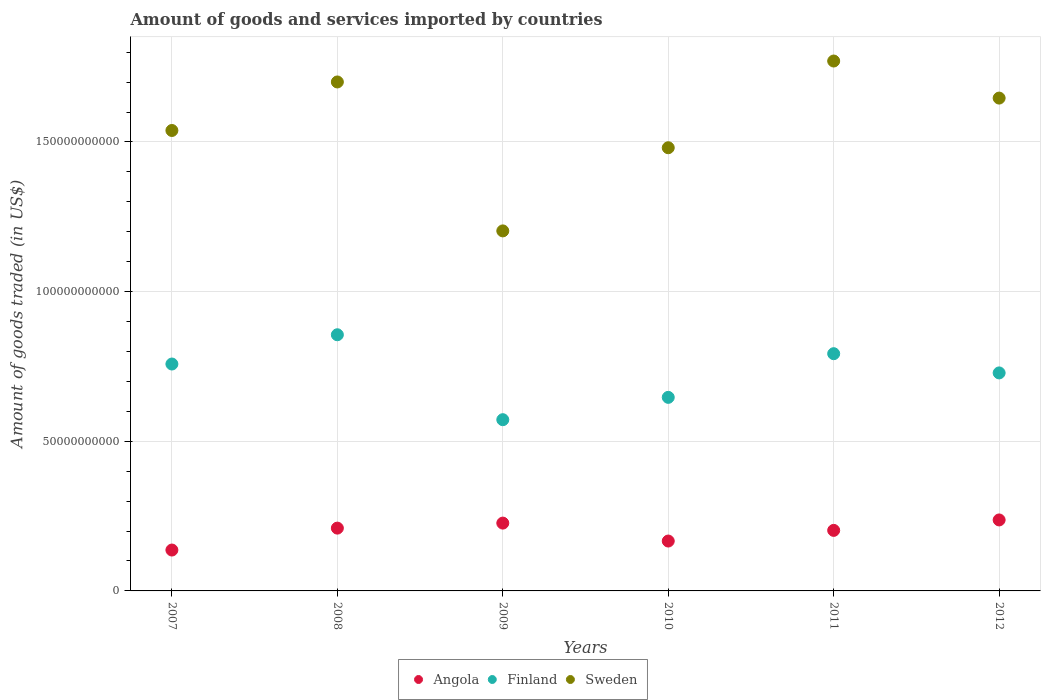Is the number of dotlines equal to the number of legend labels?
Make the answer very short. Yes. What is the total amount of goods and services imported in Sweden in 2008?
Provide a short and direct response. 1.70e+11. Across all years, what is the maximum total amount of goods and services imported in Finland?
Give a very brief answer. 8.56e+1. Across all years, what is the minimum total amount of goods and services imported in Angola?
Keep it short and to the point. 1.37e+1. In which year was the total amount of goods and services imported in Angola maximum?
Offer a terse response. 2012. In which year was the total amount of goods and services imported in Sweden minimum?
Your answer should be very brief. 2009. What is the total total amount of goods and services imported in Angola in the graph?
Offer a very short reply. 1.18e+11. What is the difference between the total amount of goods and services imported in Angola in 2011 and that in 2012?
Your answer should be very brief. -3.49e+09. What is the difference between the total amount of goods and services imported in Finland in 2011 and the total amount of goods and services imported in Angola in 2007?
Keep it short and to the point. 6.56e+1. What is the average total amount of goods and services imported in Sweden per year?
Offer a very short reply. 1.56e+11. In the year 2012, what is the difference between the total amount of goods and services imported in Angola and total amount of goods and services imported in Sweden?
Give a very brief answer. -1.41e+11. What is the ratio of the total amount of goods and services imported in Angola in 2010 to that in 2011?
Offer a very short reply. 0.82. Is the total amount of goods and services imported in Angola in 2007 less than that in 2012?
Ensure brevity in your answer.  Yes. What is the difference between the highest and the second highest total amount of goods and services imported in Angola?
Your answer should be compact. 1.06e+09. What is the difference between the highest and the lowest total amount of goods and services imported in Finland?
Your answer should be very brief. 2.84e+1. In how many years, is the total amount of goods and services imported in Finland greater than the average total amount of goods and services imported in Finland taken over all years?
Ensure brevity in your answer.  4. Is it the case that in every year, the sum of the total amount of goods and services imported in Finland and total amount of goods and services imported in Angola  is greater than the total amount of goods and services imported in Sweden?
Offer a very short reply. No. What is the difference between two consecutive major ticks on the Y-axis?
Make the answer very short. 5.00e+1. Are the values on the major ticks of Y-axis written in scientific E-notation?
Your response must be concise. No. Does the graph contain grids?
Your response must be concise. Yes. Where does the legend appear in the graph?
Your answer should be very brief. Bottom center. What is the title of the graph?
Your answer should be very brief. Amount of goods and services imported by countries. What is the label or title of the Y-axis?
Keep it short and to the point. Amount of goods traded (in US$). What is the Amount of goods traded (in US$) of Angola in 2007?
Your answer should be compact. 1.37e+1. What is the Amount of goods traded (in US$) of Finland in 2007?
Offer a very short reply. 7.58e+1. What is the Amount of goods traded (in US$) in Sweden in 2007?
Keep it short and to the point. 1.54e+11. What is the Amount of goods traded (in US$) of Angola in 2008?
Offer a terse response. 2.10e+1. What is the Amount of goods traded (in US$) of Finland in 2008?
Make the answer very short. 8.56e+1. What is the Amount of goods traded (in US$) of Sweden in 2008?
Your response must be concise. 1.70e+11. What is the Amount of goods traded (in US$) of Angola in 2009?
Your answer should be compact. 2.27e+1. What is the Amount of goods traded (in US$) of Finland in 2009?
Your answer should be compact. 5.72e+1. What is the Amount of goods traded (in US$) in Sweden in 2009?
Offer a terse response. 1.20e+11. What is the Amount of goods traded (in US$) of Angola in 2010?
Give a very brief answer. 1.67e+1. What is the Amount of goods traded (in US$) in Finland in 2010?
Ensure brevity in your answer.  6.47e+1. What is the Amount of goods traded (in US$) of Sweden in 2010?
Give a very brief answer. 1.48e+11. What is the Amount of goods traded (in US$) in Angola in 2011?
Give a very brief answer. 2.02e+1. What is the Amount of goods traded (in US$) in Finland in 2011?
Give a very brief answer. 7.93e+1. What is the Amount of goods traded (in US$) of Sweden in 2011?
Provide a succinct answer. 1.77e+11. What is the Amount of goods traded (in US$) in Angola in 2012?
Ensure brevity in your answer.  2.37e+1. What is the Amount of goods traded (in US$) of Finland in 2012?
Provide a short and direct response. 7.28e+1. What is the Amount of goods traded (in US$) in Sweden in 2012?
Keep it short and to the point. 1.65e+11. Across all years, what is the maximum Amount of goods traded (in US$) of Angola?
Make the answer very short. 2.37e+1. Across all years, what is the maximum Amount of goods traded (in US$) in Finland?
Make the answer very short. 8.56e+1. Across all years, what is the maximum Amount of goods traded (in US$) in Sweden?
Make the answer very short. 1.77e+11. Across all years, what is the minimum Amount of goods traded (in US$) in Angola?
Make the answer very short. 1.37e+1. Across all years, what is the minimum Amount of goods traded (in US$) in Finland?
Provide a succinct answer. 5.72e+1. Across all years, what is the minimum Amount of goods traded (in US$) in Sweden?
Make the answer very short. 1.20e+11. What is the total Amount of goods traded (in US$) of Angola in the graph?
Provide a succinct answer. 1.18e+11. What is the total Amount of goods traded (in US$) in Finland in the graph?
Make the answer very short. 4.35e+11. What is the total Amount of goods traded (in US$) of Sweden in the graph?
Offer a terse response. 9.34e+11. What is the difference between the Amount of goods traded (in US$) in Angola in 2007 and that in 2008?
Make the answer very short. -7.32e+09. What is the difference between the Amount of goods traded (in US$) in Finland in 2007 and that in 2008?
Offer a terse response. -9.78e+09. What is the difference between the Amount of goods traded (in US$) in Sweden in 2007 and that in 2008?
Your answer should be very brief. -1.62e+1. What is the difference between the Amount of goods traded (in US$) in Angola in 2007 and that in 2009?
Provide a short and direct response. -9.00e+09. What is the difference between the Amount of goods traded (in US$) in Finland in 2007 and that in 2009?
Give a very brief answer. 1.86e+1. What is the difference between the Amount of goods traded (in US$) in Sweden in 2007 and that in 2009?
Offer a terse response. 3.36e+1. What is the difference between the Amount of goods traded (in US$) in Angola in 2007 and that in 2010?
Make the answer very short. -3.01e+09. What is the difference between the Amount of goods traded (in US$) of Finland in 2007 and that in 2010?
Offer a very short reply. 1.11e+1. What is the difference between the Amount of goods traded (in US$) of Sweden in 2007 and that in 2010?
Your answer should be very brief. 5.76e+09. What is the difference between the Amount of goods traded (in US$) of Angola in 2007 and that in 2011?
Keep it short and to the point. -6.57e+09. What is the difference between the Amount of goods traded (in US$) of Finland in 2007 and that in 2011?
Provide a succinct answer. -3.45e+09. What is the difference between the Amount of goods traded (in US$) of Sweden in 2007 and that in 2011?
Keep it short and to the point. -2.32e+1. What is the difference between the Amount of goods traded (in US$) in Angola in 2007 and that in 2012?
Provide a succinct answer. -1.01e+1. What is the difference between the Amount of goods traded (in US$) of Finland in 2007 and that in 2012?
Your answer should be very brief. 2.97e+09. What is the difference between the Amount of goods traded (in US$) of Sweden in 2007 and that in 2012?
Offer a very short reply. -1.08e+1. What is the difference between the Amount of goods traded (in US$) in Angola in 2008 and that in 2009?
Your response must be concise. -1.68e+09. What is the difference between the Amount of goods traded (in US$) of Finland in 2008 and that in 2009?
Provide a short and direct response. 2.84e+1. What is the difference between the Amount of goods traded (in US$) of Sweden in 2008 and that in 2009?
Your response must be concise. 4.98e+1. What is the difference between the Amount of goods traded (in US$) in Angola in 2008 and that in 2010?
Offer a terse response. 4.32e+09. What is the difference between the Amount of goods traded (in US$) in Finland in 2008 and that in 2010?
Offer a very short reply. 2.09e+1. What is the difference between the Amount of goods traded (in US$) in Sweden in 2008 and that in 2010?
Give a very brief answer. 2.20e+1. What is the difference between the Amount of goods traded (in US$) of Angola in 2008 and that in 2011?
Provide a short and direct response. 7.54e+08. What is the difference between the Amount of goods traded (in US$) of Finland in 2008 and that in 2011?
Your answer should be compact. 6.33e+09. What is the difference between the Amount of goods traded (in US$) in Sweden in 2008 and that in 2011?
Make the answer very short. -7.00e+09. What is the difference between the Amount of goods traded (in US$) in Angola in 2008 and that in 2012?
Offer a terse response. -2.73e+09. What is the difference between the Amount of goods traded (in US$) of Finland in 2008 and that in 2012?
Your answer should be compact. 1.27e+1. What is the difference between the Amount of goods traded (in US$) in Sweden in 2008 and that in 2012?
Make the answer very short. 5.39e+09. What is the difference between the Amount of goods traded (in US$) in Angola in 2009 and that in 2010?
Your answer should be very brief. 5.99e+09. What is the difference between the Amount of goods traded (in US$) of Finland in 2009 and that in 2010?
Offer a very short reply. -7.46e+09. What is the difference between the Amount of goods traded (in US$) of Sweden in 2009 and that in 2010?
Keep it short and to the point. -2.78e+1. What is the difference between the Amount of goods traded (in US$) of Angola in 2009 and that in 2011?
Make the answer very short. 2.43e+09. What is the difference between the Amount of goods traded (in US$) of Finland in 2009 and that in 2011?
Your answer should be very brief. -2.21e+1. What is the difference between the Amount of goods traded (in US$) in Sweden in 2009 and that in 2011?
Your answer should be very brief. -5.68e+1. What is the difference between the Amount of goods traded (in US$) in Angola in 2009 and that in 2012?
Your answer should be compact. -1.06e+09. What is the difference between the Amount of goods traded (in US$) in Finland in 2009 and that in 2012?
Keep it short and to the point. -1.56e+1. What is the difference between the Amount of goods traded (in US$) of Sweden in 2009 and that in 2012?
Provide a short and direct response. -4.44e+1. What is the difference between the Amount of goods traded (in US$) of Angola in 2010 and that in 2011?
Offer a very short reply. -3.56e+09. What is the difference between the Amount of goods traded (in US$) in Finland in 2010 and that in 2011?
Give a very brief answer. -1.46e+1. What is the difference between the Amount of goods traded (in US$) of Sweden in 2010 and that in 2011?
Make the answer very short. -2.90e+1. What is the difference between the Amount of goods traded (in US$) of Angola in 2010 and that in 2012?
Offer a very short reply. -7.05e+09. What is the difference between the Amount of goods traded (in US$) of Finland in 2010 and that in 2012?
Offer a very short reply. -8.17e+09. What is the difference between the Amount of goods traded (in US$) in Sweden in 2010 and that in 2012?
Offer a terse response. -1.66e+1. What is the difference between the Amount of goods traded (in US$) in Angola in 2011 and that in 2012?
Ensure brevity in your answer.  -3.49e+09. What is the difference between the Amount of goods traded (in US$) of Finland in 2011 and that in 2012?
Your answer should be compact. 6.42e+09. What is the difference between the Amount of goods traded (in US$) of Sweden in 2011 and that in 2012?
Provide a short and direct response. 1.24e+1. What is the difference between the Amount of goods traded (in US$) in Angola in 2007 and the Amount of goods traded (in US$) in Finland in 2008?
Offer a very short reply. -7.19e+1. What is the difference between the Amount of goods traded (in US$) of Angola in 2007 and the Amount of goods traded (in US$) of Sweden in 2008?
Ensure brevity in your answer.  -1.56e+11. What is the difference between the Amount of goods traded (in US$) of Finland in 2007 and the Amount of goods traded (in US$) of Sweden in 2008?
Your answer should be compact. -9.42e+1. What is the difference between the Amount of goods traded (in US$) in Angola in 2007 and the Amount of goods traded (in US$) in Finland in 2009?
Your response must be concise. -4.36e+1. What is the difference between the Amount of goods traded (in US$) of Angola in 2007 and the Amount of goods traded (in US$) of Sweden in 2009?
Offer a terse response. -1.07e+11. What is the difference between the Amount of goods traded (in US$) of Finland in 2007 and the Amount of goods traded (in US$) of Sweden in 2009?
Provide a succinct answer. -4.45e+1. What is the difference between the Amount of goods traded (in US$) in Angola in 2007 and the Amount of goods traded (in US$) in Finland in 2010?
Make the answer very short. -5.10e+1. What is the difference between the Amount of goods traded (in US$) of Angola in 2007 and the Amount of goods traded (in US$) of Sweden in 2010?
Make the answer very short. -1.34e+11. What is the difference between the Amount of goods traded (in US$) of Finland in 2007 and the Amount of goods traded (in US$) of Sweden in 2010?
Your response must be concise. -7.23e+1. What is the difference between the Amount of goods traded (in US$) of Angola in 2007 and the Amount of goods traded (in US$) of Finland in 2011?
Offer a very short reply. -6.56e+1. What is the difference between the Amount of goods traded (in US$) in Angola in 2007 and the Amount of goods traded (in US$) in Sweden in 2011?
Your response must be concise. -1.63e+11. What is the difference between the Amount of goods traded (in US$) in Finland in 2007 and the Amount of goods traded (in US$) in Sweden in 2011?
Your answer should be very brief. -1.01e+11. What is the difference between the Amount of goods traded (in US$) of Angola in 2007 and the Amount of goods traded (in US$) of Finland in 2012?
Make the answer very short. -5.92e+1. What is the difference between the Amount of goods traded (in US$) of Angola in 2007 and the Amount of goods traded (in US$) of Sweden in 2012?
Your answer should be compact. -1.51e+11. What is the difference between the Amount of goods traded (in US$) in Finland in 2007 and the Amount of goods traded (in US$) in Sweden in 2012?
Provide a short and direct response. -8.89e+1. What is the difference between the Amount of goods traded (in US$) of Angola in 2008 and the Amount of goods traded (in US$) of Finland in 2009?
Your answer should be compact. -3.62e+1. What is the difference between the Amount of goods traded (in US$) of Angola in 2008 and the Amount of goods traded (in US$) of Sweden in 2009?
Ensure brevity in your answer.  -9.93e+1. What is the difference between the Amount of goods traded (in US$) in Finland in 2008 and the Amount of goods traded (in US$) in Sweden in 2009?
Keep it short and to the point. -3.47e+1. What is the difference between the Amount of goods traded (in US$) in Angola in 2008 and the Amount of goods traded (in US$) in Finland in 2010?
Give a very brief answer. -4.37e+1. What is the difference between the Amount of goods traded (in US$) in Angola in 2008 and the Amount of goods traded (in US$) in Sweden in 2010?
Make the answer very short. -1.27e+11. What is the difference between the Amount of goods traded (in US$) of Finland in 2008 and the Amount of goods traded (in US$) of Sweden in 2010?
Provide a short and direct response. -6.25e+1. What is the difference between the Amount of goods traded (in US$) of Angola in 2008 and the Amount of goods traded (in US$) of Finland in 2011?
Your answer should be very brief. -5.83e+1. What is the difference between the Amount of goods traded (in US$) of Angola in 2008 and the Amount of goods traded (in US$) of Sweden in 2011?
Offer a very short reply. -1.56e+11. What is the difference between the Amount of goods traded (in US$) of Finland in 2008 and the Amount of goods traded (in US$) of Sweden in 2011?
Offer a very short reply. -9.15e+1. What is the difference between the Amount of goods traded (in US$) in Angola in 2008 and the Amount of goods traded (in US$) in Finland in 2012?
Make the answer very short. -5.19e+1. What is the difference between the Amount of goods traded (in US$) in Angola in 2008 and the Amount of goods traded (in US$) in Sweden in 2012?
Give a very brief answer. -1.44e+11. What is the difference between the Amount of goods traded (in US$) in Finland in 2008 and the Amount of goods traded (in US$) in Sweden in 2012?
Provide a short and direct response. -7.91e+1. What is the difference between the Amount of goods traded (in US$) of Angola in 2009 and the Amount of goods traded (in US$) of Finland in 2010?
Provide a succinct answer. -4.20e+1. What is the difference between the Amount of goods traded (in US$) in Angola in 2009 and the Amount of goods traded (in US$) in Sweden in 2010?
Your answer should be very brief. -1.25e+11. What is the difference between the Amount of goods traded (in US$) of Finland in 2009 and the Amount of goods traded (in US$) of Sweden in 2010?
Offer a very short reply. -9.09e+1. What is the difference between the Amount of goods traded (in US$) of Angola in 2009 and the Amount of goods traded (in US$) of Finland in 2011?
Keep it short and to the point. -5.66e+1. What is the difference between the Amount of goods traded (in US$) in Angola in 2009 and the Amount of goods traded (in US$) in Sweden in 2011?
Provide a succinct answer. -1.54e+11. What is the difference between the Amount of goods traded (in US$) of Finland in 2009 and the Amount of goods traded (in US$) of Sweden in 2011?
Your answer should be very brief. -1.20e+11. What is the difference between the Amount of goods traded (in US$) of Angola in 2009 and the Amount of goods traded (in US$) of Finland in 2012?
Provide a short and direct response. -5.02e+1. What is the difference between the Amount of goods traded (in US$) in Angola in 2009 and the Amount of goods traded (in US$) in Sweden in 2012?
Offer a terse response. -1.42e+11. What is the difference between the Amount of goods traded (in US$) in Finland in 2009 and the Amount of goods traded (in US$) in Sweden in 2012?
Offer a terse response. -1.07e+11. What is the difference between the Amount of goods traded (in US$) of Angola in 2010 and the Amount of goods traded (in US$) of Finland in 2011?
Provide a succinct answer. -6.26e+1. What is the difference between the Amount of goods traded (in US$) of Angola in 2010 and the Amount of goods traded (in US$) of Sweden in 2011?
Your answer should be very brief. -1.60e+11. What is the difference between the Amount of goods traded (in US$) of Finland in 2010 and the Amount of goods traded (in US$) of Sweden in 2011?
Keep it short and to the point. -1.12e+11. What is the difference between the Amount of goods traded (in US$) of Angola in 2010 and the Amount of goods traded (in US$) of Finland in 2012?
Your answer should be very brief. -5.62e+1. What is the difference between the Amount of goods traded (in US$) of Angola in 2010 and the Amount of goods traded (in US$) of Sweden in 2012?
Offer a very short reply. -1.48e+11. What is the difference between the Amount of goods traded (in US$) of Finland in 2010 and the Amount of goods traded (in US$) of Sweden in 2012?
Ensure brevity in your answer.  -1.00e+11. What is the difference between the Amount of goods traded (in US$) of Angola in 2011 and the Amount of goods traded (in US$) of Finland in 2012?
Make the answer very short. -5.26e+1. What is the difference between the Amount of goods traded (in US$) in Angola in 2011 and the Amount of goods traded (in US$) in Sweden in 2012?
Ensure brevity in your answer.  -1.44e+11. What is the difference between the Amount of goods traded (in US$) in Finland in 2011 and the Amount of goods traded (in US$) in Sweden in 2012?
Make the answer very short. -8.54e+1. What is the average Amount of goods traded (in US$) in Angola per year?
Provide a short and direct response. 1.97e+1. What is the average Amount of goods traded (in US$) in Finland per year?
Offer a terse response. 7.26e+1. What is the average Amount of goods traded (in US$) in Sweden per year?
Provide a short and direct response. 1.56e+11. In the year 2007, what is the difference between the Amount of goods traded (in US$) of Angola and Amount of goods traded (in US$) of Finland?
Your response must be concise. -6.22e+1. In the year 2007, what is the difference between the Amount of goods traded (in US$) in Angola and Amount of goods traded (in US$) in Sweden?
Your answer should be very brief. -1.40e+11. In the year 2007, what is the difference between the Amount of goods traded (in US$) of Finland and Amount of goods traded (in US$) of Sweden?
Your answer should be compact. -7.80e+1. In the year 2008, what is the difference between the Amount of goods traded (in US$) of Angola and Amount of goods traded (in US$) of Finland?
Give a very brief answer. -6.46e+1. In the year 2008, what is the difference between the Amount of goods traded (in US$) of Angola and Amount of goods traded (in US$) of Sweden?
Ensure brevity in your answer.  -1.49e+11. In the year 2008, what is the difference between the Amount of goods traded (in US$) in Finland and Amount of goods traded (in US$) in Sweden?
Give a very brief answer. -8.45e+1. In the year 2009, what is the difference between the Amount of goods traded (in US$) of Angola and Amount of goods traded (in US$) of Finland?
Offer a very short reply. -3.46e+1. In the year 2009, what is the difference between the Amount of goods traded (in US$) in Angola and Amount of goods traded (in US$) in Sweden?
Offer a terse response. -9.76e+1. In the year 2009, what is the difference between the Amount of goods traded (in US$) of Finland and Amount of goods traded (in US$) of Sweden?
Your answer should be very brief. -6.31e+1. In the year 2010, what is the difference between the Amount of goods traded (in US$) of Angola and Amount of goods traded (in US$) of Finland?
Give a very brief answer. -4.80e+1. In the year 2010, what is the difference between the Amount of goods traded (in US$) of Angola and Amount of goods traded (in US$) of Sweden?
Your answer should be very brief. -1.31e+11. In the year 2010, what is the difference between the Amount of goods traded (in US$) in Finland and Amount of goods traded (in US$) in Sweden?
Offer a terse response. -8.34e+1. In the year 2011, what is the difference between the Amount of goods traded (in US$) of Angola and Amount of goods traded (in US$) of Finland?
Your answer should be compact. -5.90e+1. In the year 2011, what is the difference between the Amount of goods traded (in US$) in Angola and Amount of goods traded (in US$) in Sweden?
Offer a very short reply. -1.57e+11. In the year 2011, what is the difference between the Amount of goods traded (in US$) of Finland and Amount of goods traded (in US$) of Sweden?
Offer a terse response. -9.78e+1. In the year 2012, what is the difference between the Amount of goods traded (in US$) in Angola and Amount of goods traded (in US$) in Finland?
Give a very brief answer. -4.91e+1. In the year 2012, what is the difference between the Amount of goods traded (in US$) of Angola and Amount of goods traded (in US$) of Sweden?
Your answer should be very brief. -1.41e+11. In the year 2012, what is the difference between the Amount of goods traded (in US$) of Finland and Amount of goods traded (in US$) of Sweden?
Ensure brevity in your answer.  -9.18e+1. What is the ratio of the Amount of goods traded (in US$) of Angola in 2007 to that in 2008?
Give a very brief answer. 0.65. What is the ratio of the Amount of goods traded (in US$) of Finland in 2007 to that in 2008?
Offer a terse response. 0.89. What is the ratio of the Amount of goods traded (in US$) of Sweden in 2007 to that in 2008?
Provide a succinct answer. 0.9. What is the ratio of the Amount of goods traded (in US$) of Angola in 2007 to that in 2009?
Offer a very short reply. 0.6. What is the ratio of the Amount of goods traded (in US$) in Finland in 2007 to that in 2009?
Give a very brief answer. 1.33. What is the ratio of the Amount of goods traded (in US$) in Sweden in 2007 to that in 2009?
Your answer should be very brief. 1.28. What is the ratio of the Amount of goods traded (in US$) of Angola in 2007 to that in 2010?
Your answer should be compact. 0.82. What is the ratio of the Amount of goods traded (in US$) in Finland in 2007 to that in 2010?
Make the answer very short. 1.17. What is the ratio of the Amount of goods traded (in US$) in Sweden in 2007 to that in 2010?
Keep it short and to the point. 1.04. What is the ratio of the Amount of goods traded (in US$) in Angola in 2007 to that in 2011?
Offer a terse response. 0.68. What is the ratio of the Amount of goods traded (in US$) in Finland in 2007 to that in 2011?
Keep it short and to the point. 0.96. What is the ratio of the Amount of goods traded (in US$) in Sweden in 2007 to that in 2011?
Make the answer very short. 0.87. What is the ratio of the Amount of goods traded (in US$) in Angola in 2007 to that in 2012?
Give a very brief answer. 0.58. What is the ratio of the Amount of goods traded (in US$) of Finland in 2007 to that in 2012?
Keep it short and to the point. 1.04. What is the ratio of the Amount of goods traded (in US$) in Sweden in 2007 to that in 2012?
Give a very brief answer. 0.93. What is the ratio of the Amount of goods traded (in US$) of Angola in 2008 to that in 2009?
Provide a succinct answer. 0.93. What is the ratio of the Amount of goods traded (in US$) in Finland in 2008 to that in 2009?
Give a very brief answer. 1.5. What is the ratio of the Amount of goods traded (in US$) of Sweden in 2008 to that in 2009?
Your response must be concise. 1.41. What is the ratio of the Amount of goods traded (in US$) of Angola in 2008 to that in 2010?
Offer a very short reply. 1.26. What is the ratio of the Amount of goods traded (in US$) of Finland in 2008 to that in 2010?
Provide a succinct answer. 1.32. What is the ratio of the Amount of goods traded (in US$) of Sweden in 2008 to that in 2010?
Your answer should be very brief. 1.15. What is the ratio of the Amount of goods traded (in US$) in Angola in 2008 to that in 2011?
Your answer should be compact. 1.04. What is the ratio of the Amount of goods traded (in US$) of Finland in 2008 to that in 2011?
Your answer should be compact. 1.08. What is the ratio of the Amount of goods traded (in US$) in Sweden in 2008 to that in 2011?
Provide a succinct answer. 0.96. What is the ratio of the Amount of goods traded (in US$) of Angola in 2008 to that in 2012?
Make the answer very short. 0.88. What is the ratio of the Amount of goods traded (in US$) of Finland in 2008 to that in 2012?
Your answer should be compact. 1.18. What is the ratio of the Amount of goods traded (in US$) in Sweden in 2008 to that in 2012?
Keep it short and to the point. 1.03. What is the ratio of the Amount of goods traded (in US$) of Angola in 2009 to that in 2010?
Keep it short and to the point. 1.36. What is the ratio of the Amount of goods traded (in US$) in Finland in 2009 to that in 2010?
Ensure brevity in your answer.  0.88. What is the ratio of the Amount of goods traded (in US$) in Sweden in 2009 to that in 2010?
Ensure brevity in your answer.  0.81. What is the ratio of the Amount of goods traded (in US$) of Angola in 2009 to that in 2011?
Offer a very short reply. 1.12. What is the ratio of the Amount of goods traded (in US$) in Finland in 2009 to that in 2011?
Keep it short and to the point. 0.72. What is the ratio of the Amount of goods traded (in US$) of Sweden in 2009 to that in 2011?
Offer a terse response. 0.68. What is the ratio of the Amount of goods traded (in US$) of Angola in 2009 to that in 2012?
Your answer should be very brief. 0.96. What is the ratio of the Amount of goods traded (in US$) of Finland in 2009 to that in 2012?
Offer a terse response. 0.79. What is the ratio of the Amount of goods traded (in US$) in Sweden in 2009 to that in 2012?
Provide a succinct answer. 0.73. What is the ratio of the Amount of goods traded (in US$) in Angola in 2010 to that in 2011?
Provide a succinct answer. 0.82. What is the ratio of the Amount of goods traded (in US$) in Finland in 2010 to that in 2011?
Provide a short and direct response. 0.82. What is the ratio of the Amount of goods traded (in US$) in Sweden in 2010 to that in 2011?
Provide a short and direct response. 0.84. What is the ratio of the Amount of goods traded (in US$) in Angola in 2010 to that in 2012?
Ensure brevity in your answer.  0.7. What is the ratio of the Amount of goods traded (in US$) of Finland in 2010 to that in 2012?
Keep it short and to the point. 0.89. What is the ratio of the Amount of goods traded (in US$) in Sweden in 2010 to that in 2012?
Give a very brief answer. 0.9. What is the ratio of the Amount of goods traded (in US$) of Angola in 2011 to that in 2012?
Your response must be concise. 0.85. What is the ratio of the Amount of goods traded (in US$) in Finland in 2011 to that in 2012?
Keep it short and to the point. 1.09. What is the ratio of the Amount of goods traded (in US$) of Sweden in 2011 to that in 2012?
Provide a succinct answer. 1.08. What is the difference between the highest and the second highest Amount of goods traded (in US$) in Angola?
Offer a terse response. 1.06e+09. What is the difference between the highest and the second highest Amount of goods traded (in US$) in Finland?
Keep it short and to the point. 6.33e+09. What is the difference between the highest and the second highest Amount of goods traded (in US$) in Sweden?
Your answer should be very brief. 7.00e+09. What is the difference between the highest and the lowest Amount of goods traded (in US$) in Angola?
Keep it short and to the point. 1.01e+1. What is the difference between the highest and the lowest Amount of goods traded (in US$) of Finland?
Ensure brevity in your answer.  2.84e+1. What is the difference between the highest and the lowest Amount of goods traded (in US$) in Sweden?
Offer a very short reply. 5.68e+1. 